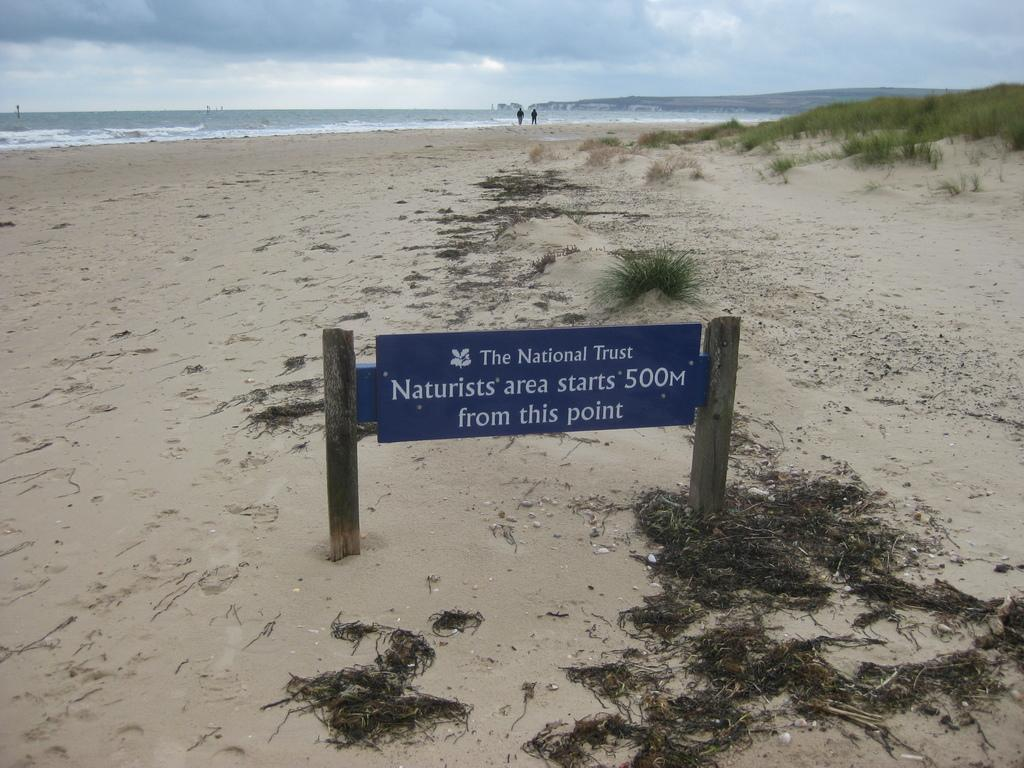What is the main object present in the image? There is a name board in the image. Where is the name board located? The name board is located on the beach. How many people are visible in the image? There are two persons visible in the image. What is the background of the image? The two persons are in front of the ocean, and the sky is visible in the image. What can be seen in the sky? Clouds are present in the sky. How many boats are visible in the image? There are no boats visible in the image. What type of line is being used by the persons in the image? There is no line present in the image; the two persons are simply standing in front of the ocean. 